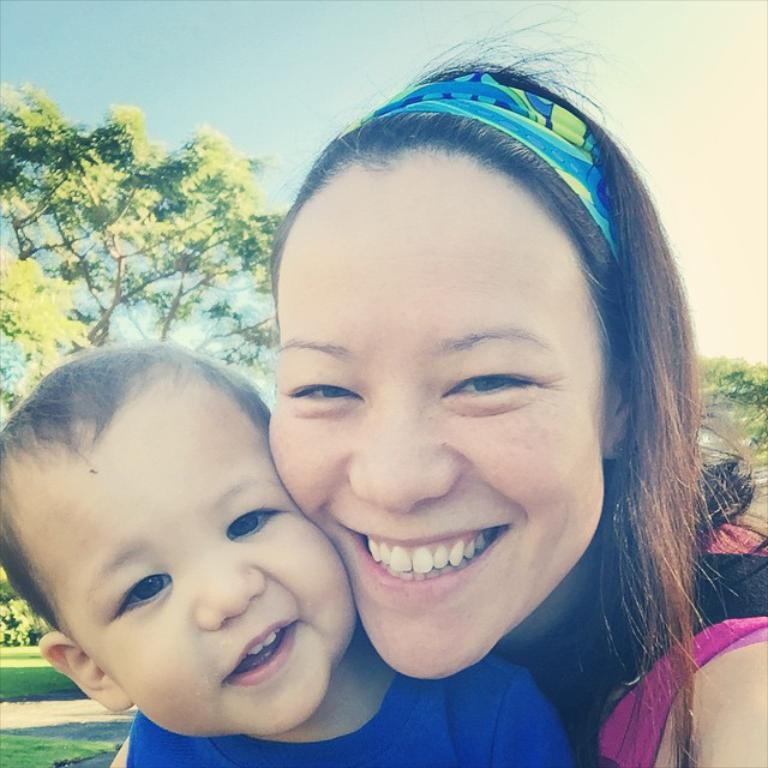Who are the people in the image? There is a woman and a boy in the image. What expressions do the woman and the boy have? Both the woman and the boy are smiling in the image. What can be seen in the background of the image? There are trees, grass, and the sky visible in the background of the image. What type of bread is the wren holding in the image? There is no wren or bread present in the image. Where is the bed located in the image? There is no bed present in the image. 